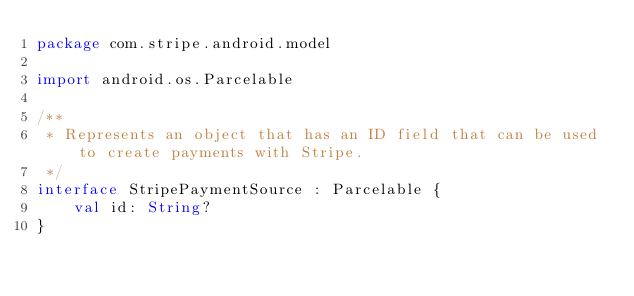Convert code to text. <code><loc_0><loc_0><loc_500><loc_500><_Kotlin_>package com.stripe.android.model

import android.os.Parcelable

/**
 * Represents an object that has an ID field that can be used to create payments with Stripe.
 */
interface StripePaymentSource : Parcelable {
    val id: String?
}
</code> 